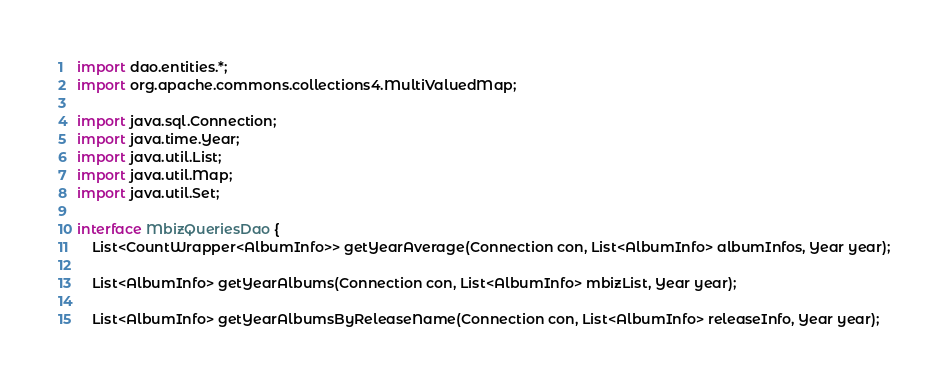<code> <loc_0><loc_0><loc_500><loc_500><_Java_>import dao.entities.*;
import org.apache.commons.collections4.MultiValuedMap;

import java.sql.Connection;
import java.time.Year;
import java.util.List;
import java.util.Map;
import java.util.Set;

interface MbizQueriesDao {
    List<CountWrapper<AlbumInfo>> getYearAverage(Connection con, List<AlbumInfo> albumInfos, Year year);

    List<AlbumInfo> getYearAlbums(Connection con, List<AlbumInfo> mbizList, Year year);

    List<AlbumInfo> getYearAlbumsByReleaseName(Connection con, List<AlbumInfo> releaseInfo, Year year);
</code> 